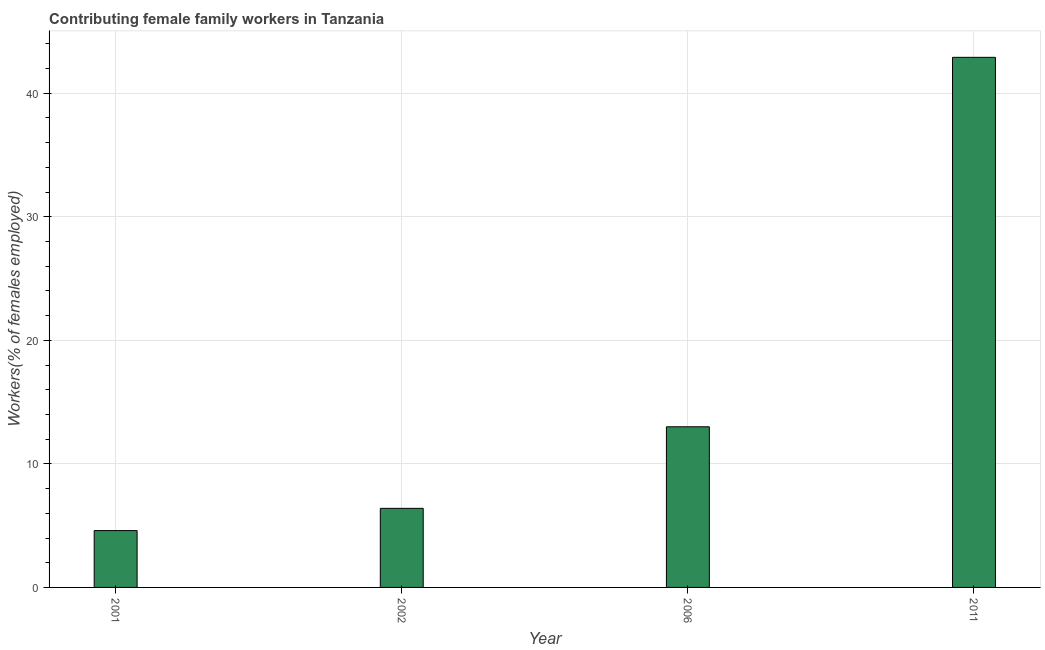What is the title of the graph?
Your response must be concise. Contributing female family workers in Tanzania. What is the label or title of the X-axis?
Keep it short and to the point. Year. What is the label or title of the Y-axis?
Provide a succinct answer. Workers(% of females employed). What is the contributing female family workers in 2001?
Offer a very short reply. 4.6. Across all years, what is the maximum contributing female family workers?
Keep it short and to the point. 42.9. Across all years, what is the minimum contributing female family workers?
Provide a succinct answer. 4.6. What is the sum of the contributing female family workers?
Offer a very short reply. 66.9. What is the average contributing female family workers per year?
Provide a short and direct response. 16.73. What is the median contributing female family workers?
Provide a succinct answer. 9.7. What is the ratio of the contributing female family workers in 2002 to that in 2006?
Offer a very short reply. 0.49. Is the contributing female family workers in 2006 less than that in 2011?
Offer a very short reply. Yes. Is the difference between the contributing female family workers in 2001 and 2006 greater than the difference between any two years?
Provide a succinct answer. No. What is the difference between the highest and the second highest contributing female family workers?
Offer a very short reply. 29.9. Is the sum of the contributing female family workers in 2001 and 2011 greater than the maximum contributing female family workers across all years?
Provide a succinct answer. Yes. What is the difference between the highest and the lowest contributing female family workers?
Your answer should be compact. 38.3. How many bars are there?
Ensure brevity in your answer.  4. Are the values on the major ticks of Y-axis written in scientific E-notation?
Your response must be concise. No. What is the Workers(% of females employed) in 2001?
Offer a terse response. 4.6. What is the Workers(% of females employed) of 2002?
Provide a short and direct response. 6.4. What is the Workers(% of females employed) of 2011?
Provide a succinct answer. 42.9. What is the difference between the Workers(% of females employed) in 2001 and 2002?
Keep it short and to the point. -1.8. What is the difference between the Workers(% of females employed) in 2001 and 2011?
Your response must be concise. -38.3. What is the difference between the Workers(% of females employed) in 2002 and 2011?
Make the answer very short. -36.5. What is the difference between the Workers(% of females employed) in 2006 and 2011?
Offer a terse response. -29.9. What is the ratio of the Workers(% of females employed) in 2001 to that in 2002?
Offer a terse response. 0.72. What is the ratio of the Workers(% of females employed) in 2001 to that in 2006?
Keep it short and to the point. 0.35. What is the ratio of the Workers(% of females employed) in 2001 to that in 2011?
Offer a very short reply. 0.11. What is the ratio of the Workers(% of females employed) in 2002 to that in 2006?
Make the answer very short. 0.49. What is the ratio of the Workers(% of females employed) in 2002 to that in 2011?
Give a very brief answer. 0.15. What is the ratio of the Workers(% of females employed) in 2006 to that in 2011?
Provide a short and direct response. 0.3. 